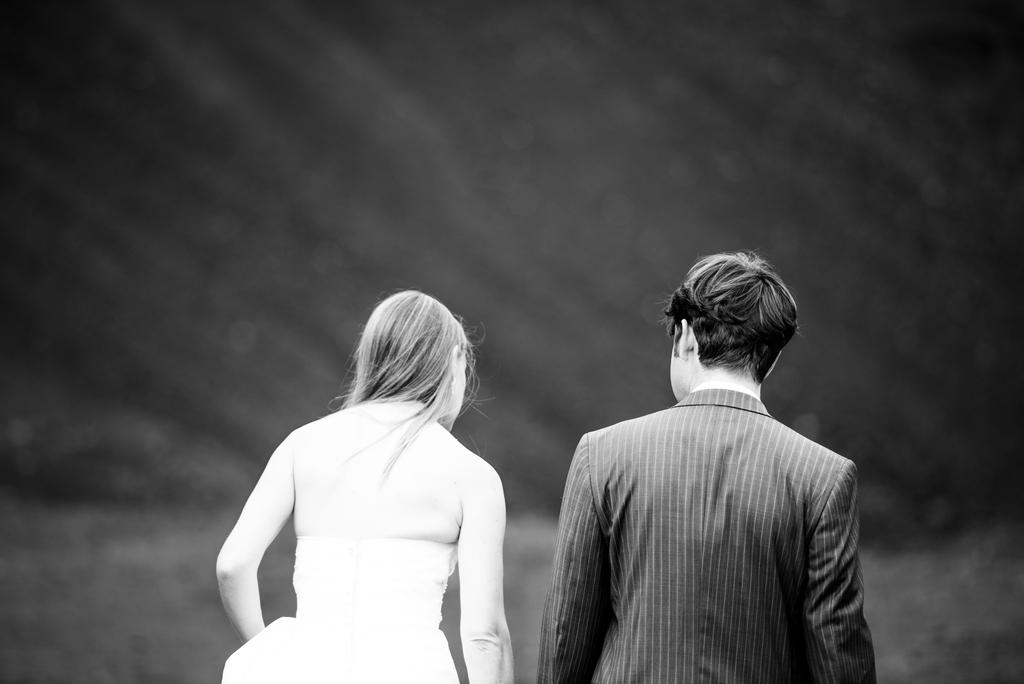What is the color scheme of the image? The image is black and white. Can you describe the subjects in the image? There is a couple in the image. What word is being spoken by the couple in the image? There is no indication of any spoken words in the image, as it is a black and white photograph. What is the range of emotions displayed by the couple in the image? The image is black and white, so it is difficult to determine the range of emotions displayed by the couple. 